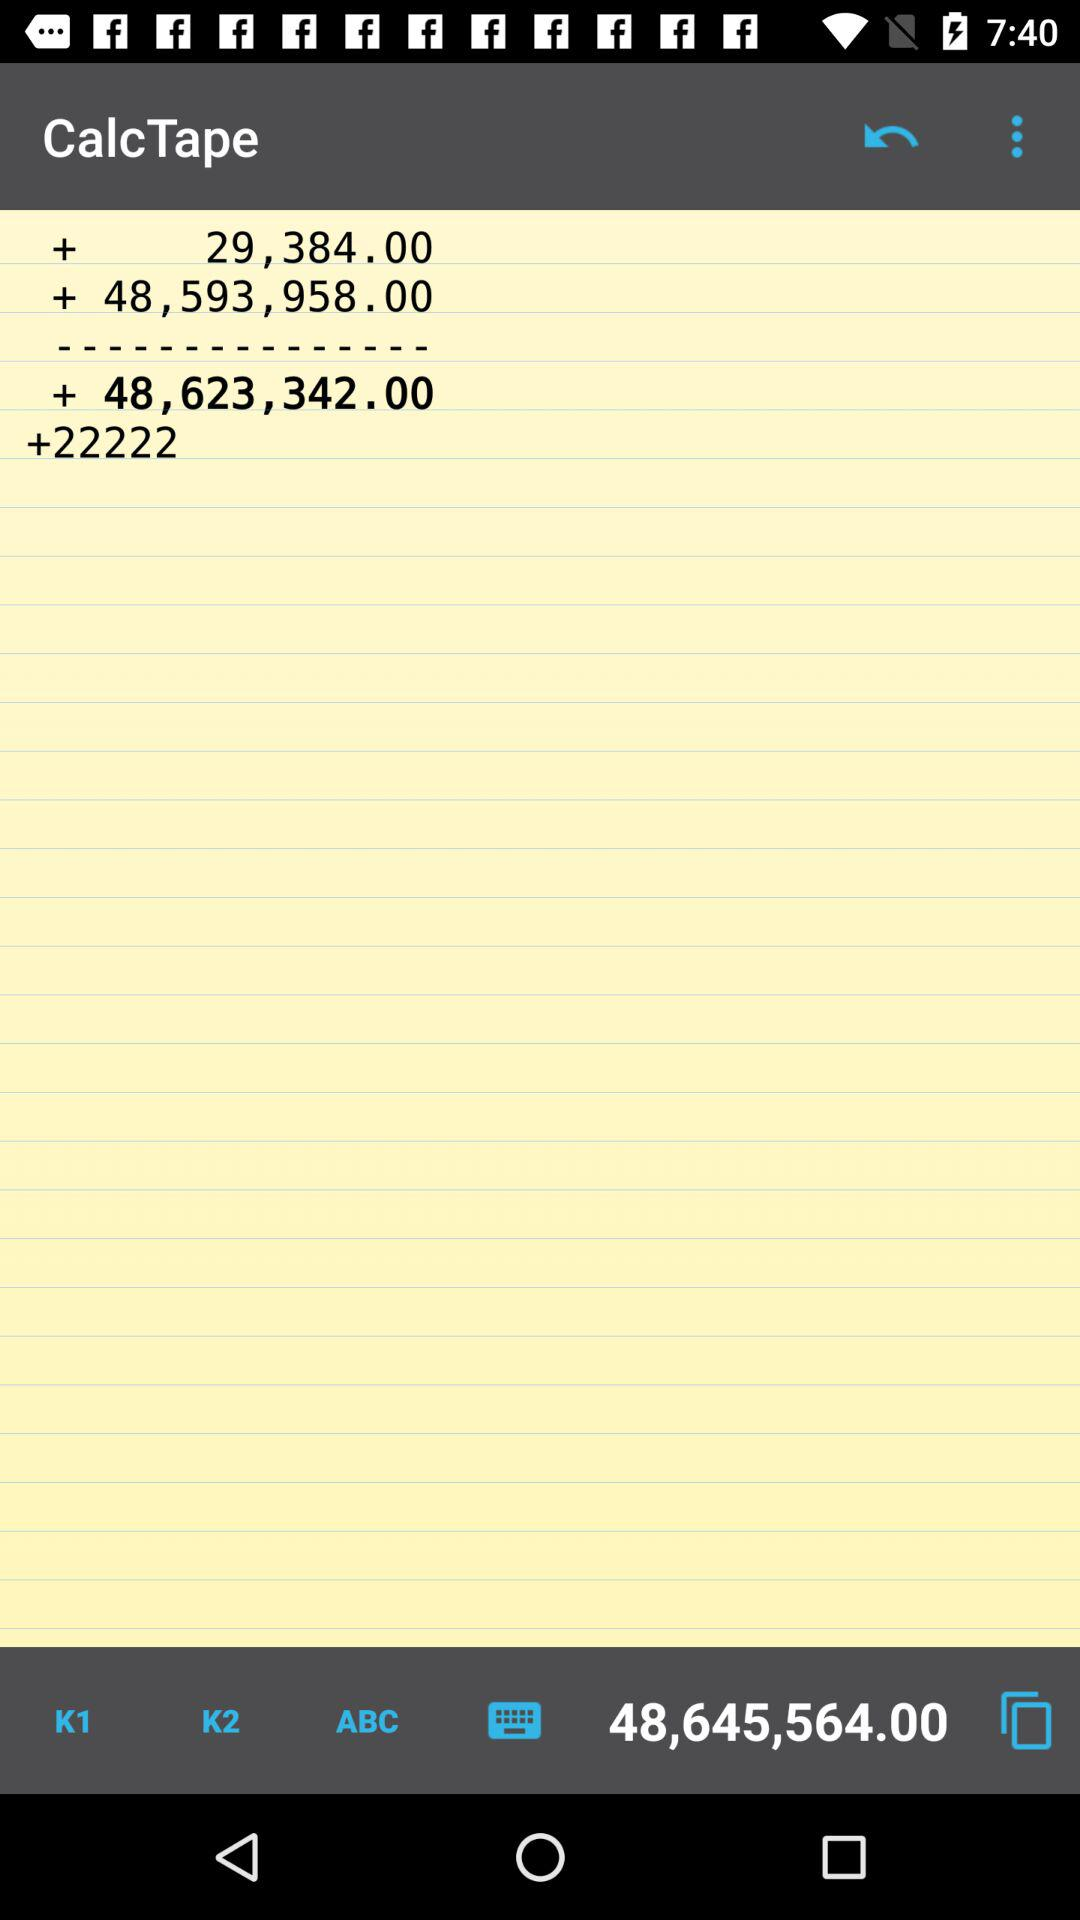What value is shown at the bottom of the screen? The value shown at the bottom of the screen is 48,645,564.00. 